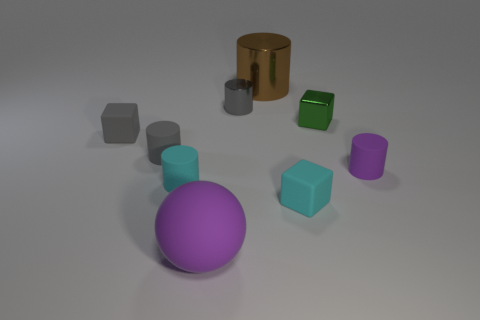What material is the small cylinder that is right of the big rubber ball and to the left of the small green metal thing?
Keep it short and to the point. Metal. What shape is the tiny purple object that is the same material as the small cyan cylinder?
Your response must be concise. Cylinder. Is there anything else that has the same shape as the tiny green thing?
Offer a terse response. Yes. Is the material of the small cylinder that is in front of the purple rubber cylinder the same as the green cube?
Your answer should be very brief. No. There is a tiny green thing that is in front of the tiny gray metallic cylinder; what is it made of?
Offer a terse response. Metal. There is a gray rubber thing that is to the right of the rubber cube to the left of the large shiny cylinder; what is its size?
Ensure brevity in your answer.  Small. What number of gray things are the same size as the purple matte ball?
Offer a very short reply. 0. Do the large object that is in front of the gray shiny cylinder and the matte cylinder right of the small metal cylinder have the same color?
Your response must be concise. Yes. There is a large purple rubber thing; are there any blocks on the left side of it?
Ensure brevity in your answer.  Yes. There is a cylinder that is right of the small gray metal cylinder and in front of the tiny gray cube; what is its color?
Offer a very short reply. Purple. 